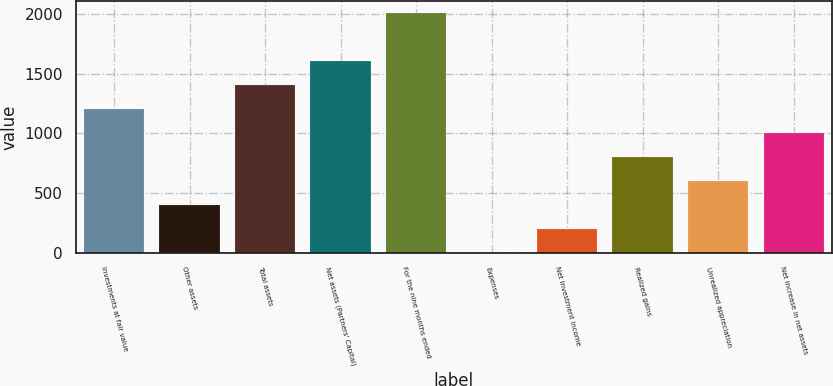Convert chart. <chart><loc_0><loc_0><loc_500><loc_500><bar_chart><fcel>Investments at fair value<fcel>Other assets<fcel>Total assets<fcel>Net assets (Partners' Capital)<fcel>For the nine months ended<fcel>Expenses<fcel>Net investment income<fcel>Realized gains<fcel>Unrealized appreciation<fcel>Net increase in net assets<nl><fcel>1205<fcel>403<fcel>1405.5<fcel>1606<fcel>2007<fcel>2<fcel>202.5<fcel>804<fcel>603.5<fcel>1004.5<nl></chart> 